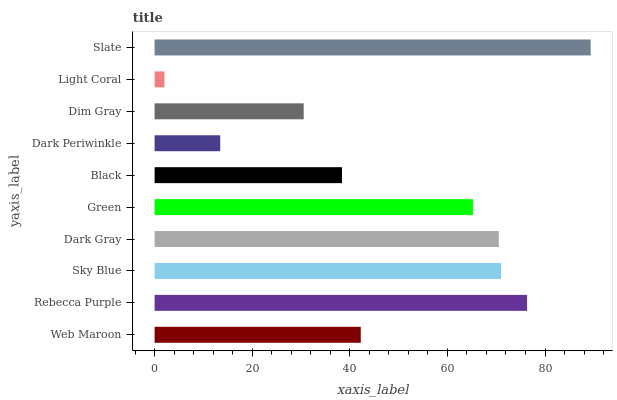Is Light Coral the minimum?
Answer yes or no. Yes. Is Slate the maximum?
Answer yes or no. Yes. Is Rebecca Purple the minimum?
Answer yes or no. No. Is Rebecca Purple the maximum?
Answer yes or no. No. Is Rebecca Purple greater than Web Maroon?
Answer yes or no. Yes. Is Web Maroon less than Rebecca Purple?
Answer yes or no. Yes. Is Web Maroon greater than Rebecca Purple?
Answer yes or no. No. Is Rebecca Purple less than Web Maroon?
Answer yes or no. No. Is Green the high median?
Answer yes or no. Yes. Is Web Maroon the low median?
Answer yes or no. Yes. Is Sky Blue the high median?
Answer yes or no. No. Is Slate the low median?
Answer yes or no. No. 